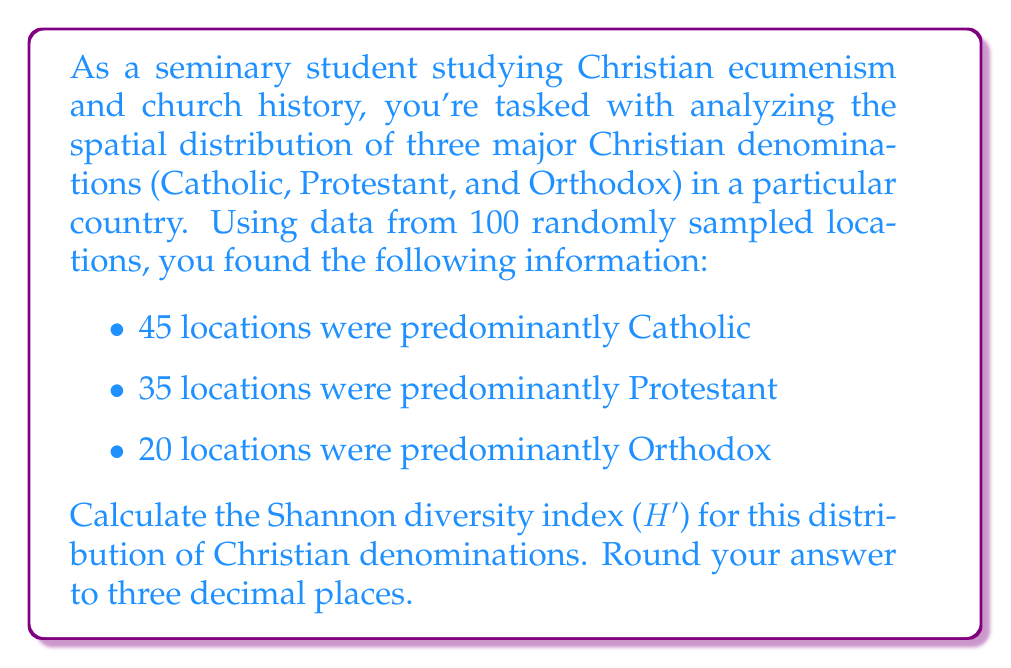Give your solution to this math problem. The Shannon diversity index (H') is a measure used in ecology and information theory to quantify diversity in a dataset. In this context, we can use it to measure the diversity of Christian denominations across the sampled locations.

The formula for the Shannon diversity index is:

$$H' = -\sum_{i=1}^{R} p_i \ln(p_i)$$

Where:
- $R$ is the number of distinct categories (in this case, denominations)
- $p_i$ is the proportion of individuals belonging to the $i$-th species

Step 1: Calculate the proportions for each denomination
Total samples: 45 + 35 + 20 = 100

$p_{Catholic} = \frac{45}{100} = 0.45$
$p_{Protestant} = \frac{35}{100} = 0.35$
$p_{Orthodox} = \frac{20}{100} = 0.20$

Step 2: Calculate $-p_i \ln(p_i)$ for each denomination

Catholic: $-0.45 \ln(0.45) = 0.359149$
Protestant: $-0.35 \ln(0.35) = 0.367098$
Orthodox: $-0.20 \ln(0.20) = 0.321887$

Step 3: Sum the values

$H' = 0.359149 + 0.367098 + 0.321887 = 1.048134$

Step 4: Round to three decimal places

$H' \approx 1.048$
Answer: 1.048 